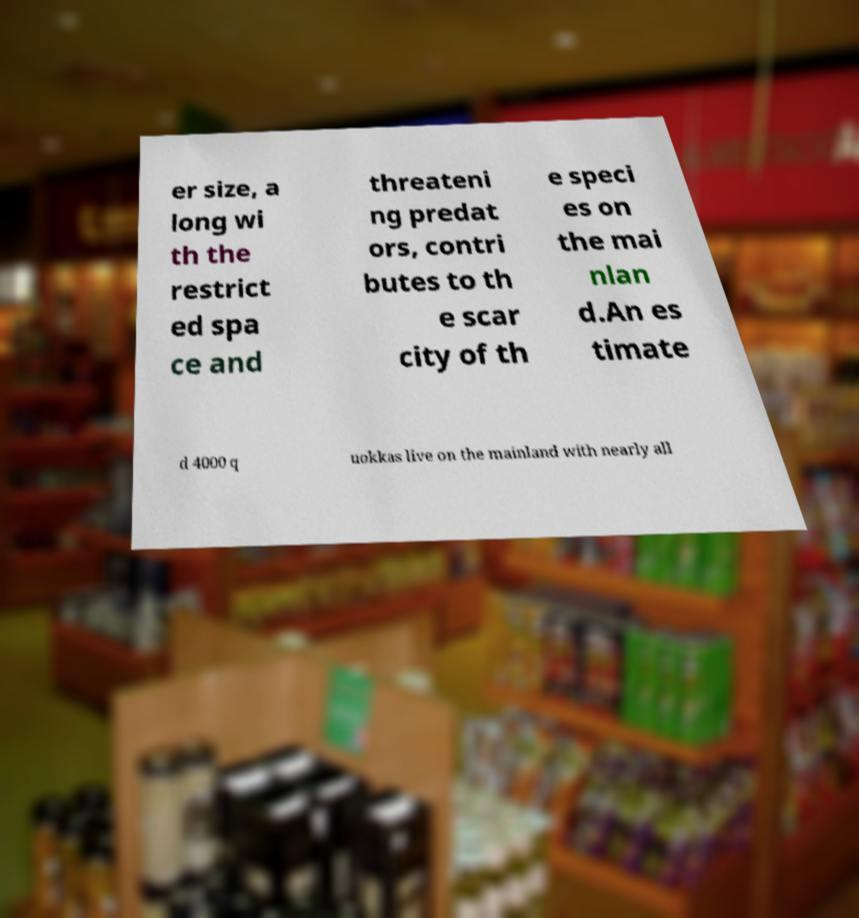Could you extract and type out the text from this image? er size, a long wi th the restrict ed spa ce and threateni ng predat ors, contri butes to th e scar city of th e speci es on the mai nlan d.An es timate d 4000 q uokkas live on the mainland with nearly all 